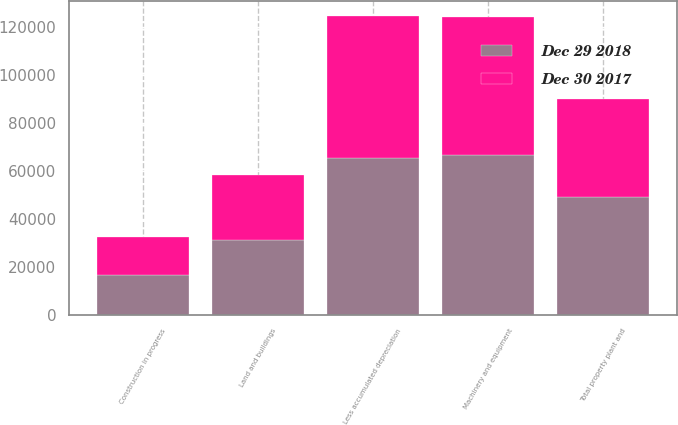Convert chart to OTSL. <chart><loc_0><loc_0><loc_500><loc_500><stacked_bar_chart><ecel><fcel>Land and buildings<fcel>Machinery and equipment<fcel>Construction in progress<fcel>Total property plant and<fcel>Less accumulated depreciation<nl><fcel>Dec 29 2018<fcel>30954<fcel>66721<fcel>16643<fcel>48976<fcel>65342<nl><fcel>Dec 30 2017<fcel>27391<fcel>57192<fcel>15812<fcel>41109<fcel>59286<nl></chart> 